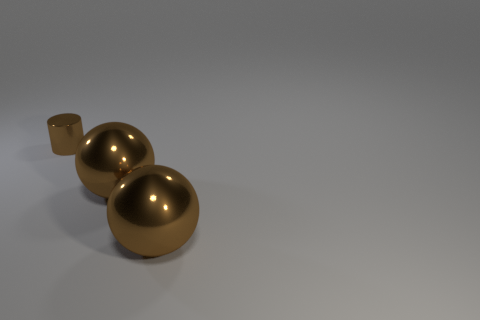Is there any other thing that is the same size as the brown metallic cylinder?
Your answer should be compact. No. The shiny cylinder has what size?
Provide a short and direct response. Small. How many shiny cylinders are there?
Make the answer very short. 1. What number of objects are either metallic cylinders or shiny balls?
Make the answer very short. 3. Is there any other thing that has the same color as the metallic cylinder?
Keep it short and to the point. Yes. What material is the small brown cylinder?
Provide a short and direct response. Metal. What number of other objects are the same material as the small brown cylinder?
Ensure brevity in your answer.  2. Is there a big purple object of the same shape as the small brown thing?
Keep it short and to the point. No. Is there a green matte thing that has the same size as the brown shiny cylinder?
Ensure brevity in your answer.  No. Is the number of metal cubes less than the number of shiny cylinders?
Give a very brief answer. Yes. 